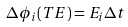Convert formula to latex. <formula><loc_0><loc_0><loc_500><loc_500>\Delta \phi _ { i } ( T E ) = E _ { i } \Delta t</formula> 